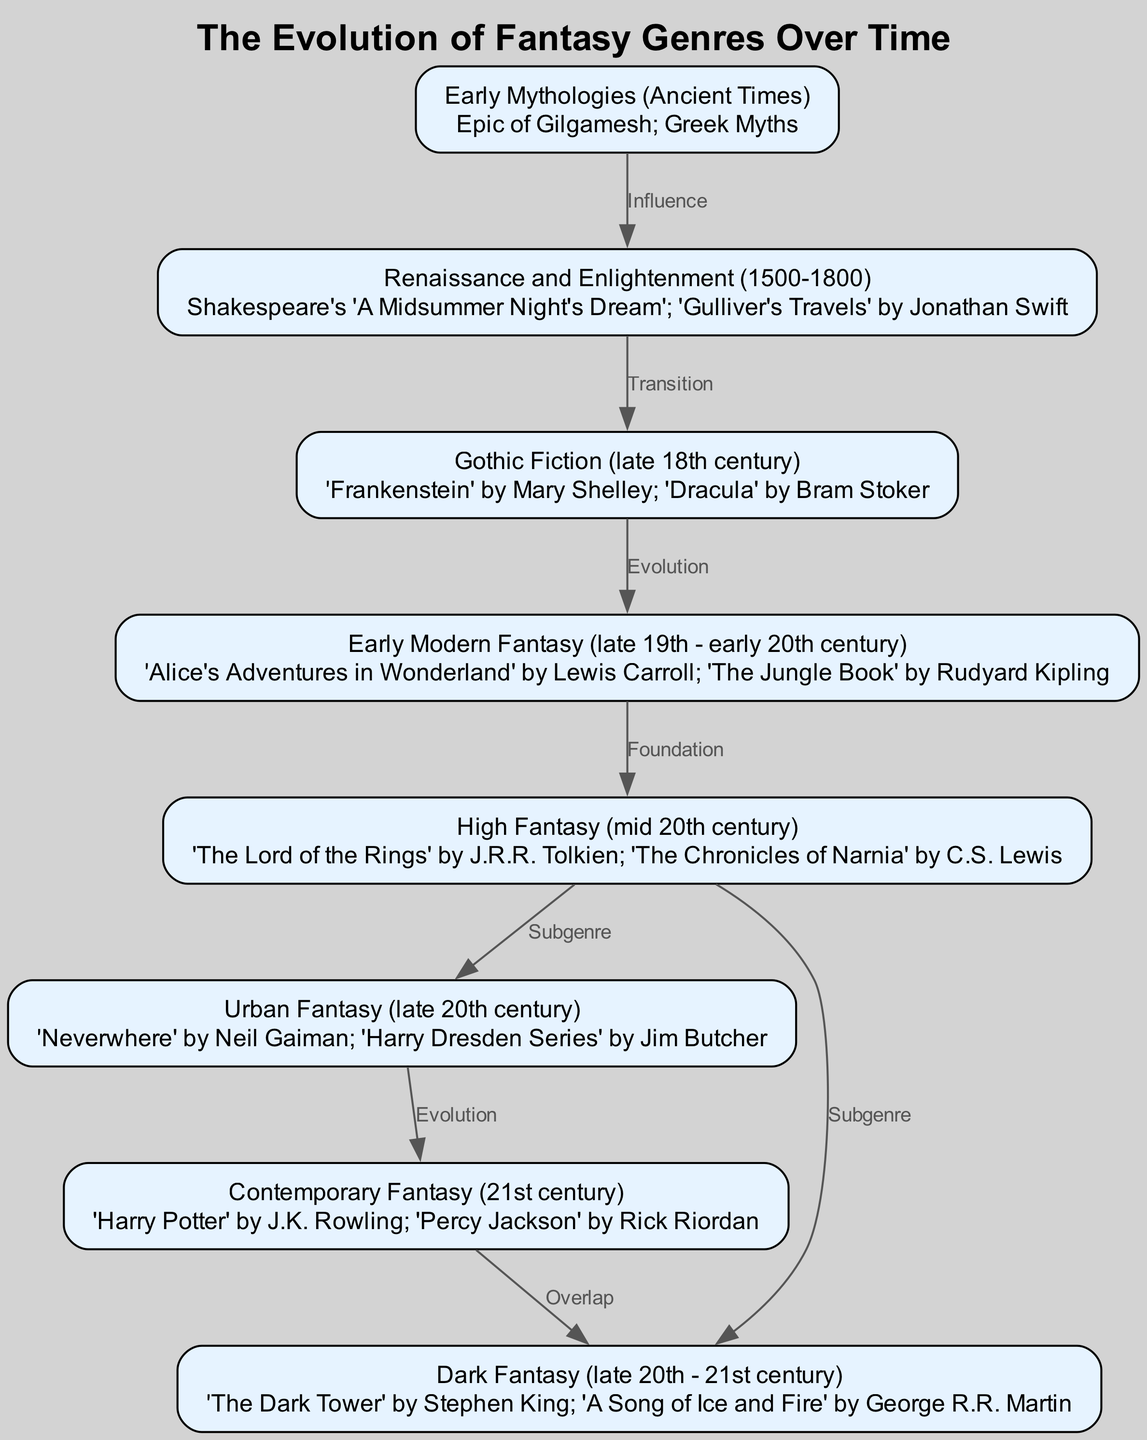What is the first genre depicted in the diagram? The diagram starts with "Early Mythologies (Ancient Times)" which is the first node listed.
Answer: Early Mythologies (Ancient Times) How many major genres are highlighted in the diagram? There are a total of eight genres listed as nodes in the diagram.
Answer: 8 Which work is associated with "High Fantasy"? According to the diagram, "The Lord of the Rings" by J.R.R. Tolkien is specifically associated with "High Fantasy".
Answer: The Lord of the Rings What type of relationship exists between "Urban Fantasy" and "Contemporary Fantasy"? The edge between "Urban Fantasy" and "Contemporary Fantasy" is labeled "Evolution," indicating a development or progress from one genre to the other.
Answer: Evolution Which two genres have a direct overlap according to the diagram? The diagram shows an overlap between "Contemporary Fantasy" and "Dark Fantasy."
Answer: Contemporary Fantasy and Dark Fantasy What significant transition occurs between the "Renaissance and Enlightenment" and "Gothic Fiction"? The diagram indicates a "Transition" relationship from "Renaissance and Enlightenment" to "Gothic Fiction," suggesting a notable change from one to the other.
Answer: Transition How does "High Fantasy" influence "Urban Fantasy"? The diagram indicates that "High Fantasy" is a precursor and a "Subgenre" that influences "Urban Fantasy," showing a relationship of development from one genre to the next.
Answer: Subgenre What influential work is associated with "Dark Fantasy"? "A Song of Ice and Fire" by George R.R. Martin is specifically mentioned under the "Dark Fantasy" genre in the diagram.
Answer: A Song of Ice and Fire 